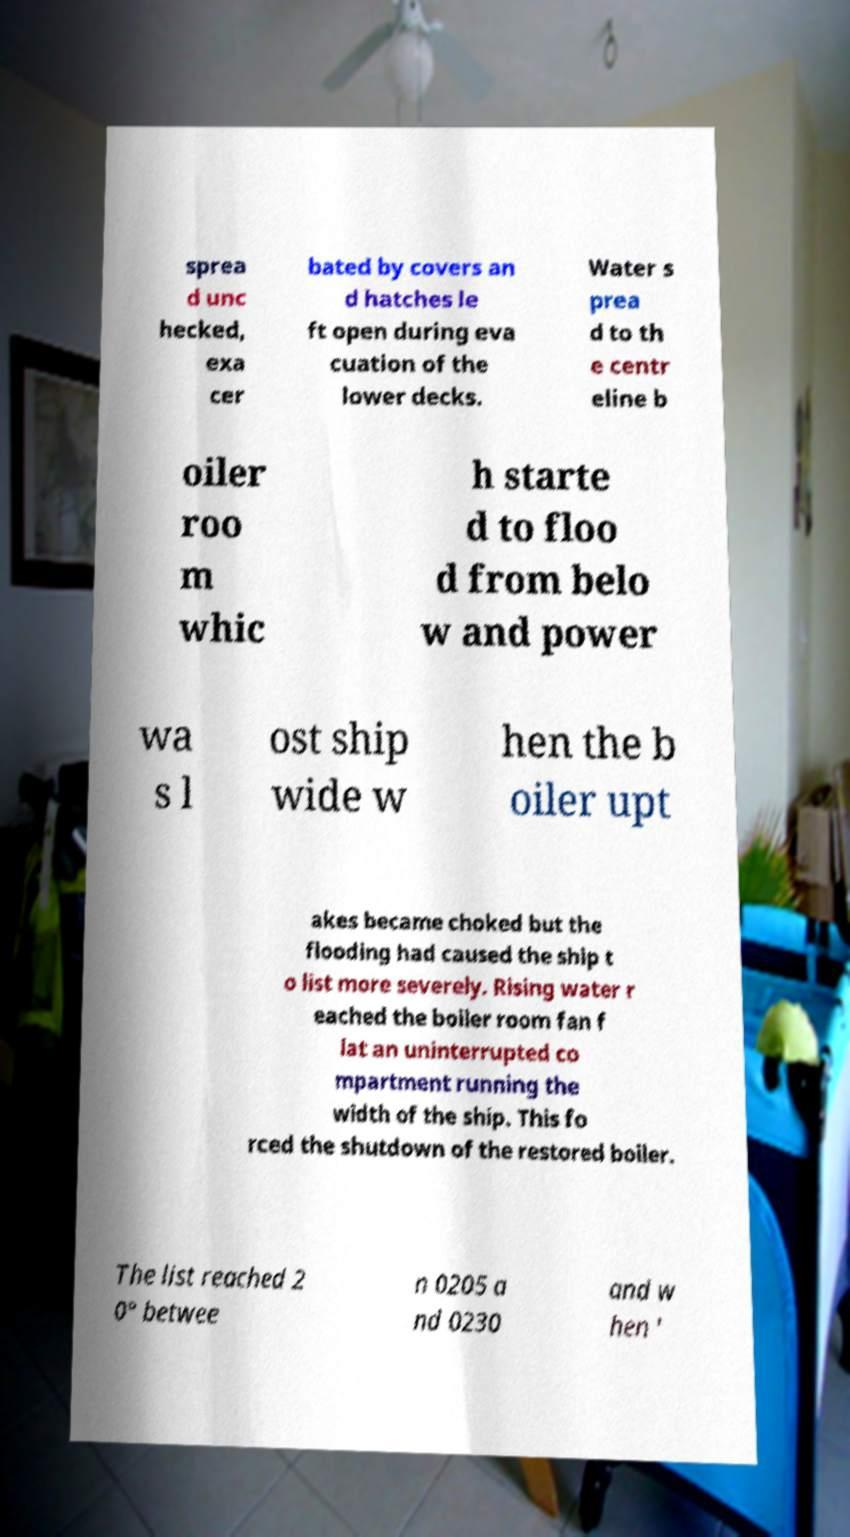What messages or text are displayed in this image? I need them in a readable, typed format. sprea d unc hecked, exa cer bated by covers an d hatches le ft open during eva cuation of the lower decks. Water s prea d to th e centr eline b oiler roo m whic h starte d to floo d from belo w and power wa s l ost ship wide w hen the b oiler upt akes became choked but the flooding had caused the ship t o list more severely. Rising water r eached the boiler room fan f lat an uninterrupted co mpartment running the width of the ship. This fo rced the shutdown of the restored boiler. The list reached 2 0° betwee n 0205 a nd 0230 and w hen ' 